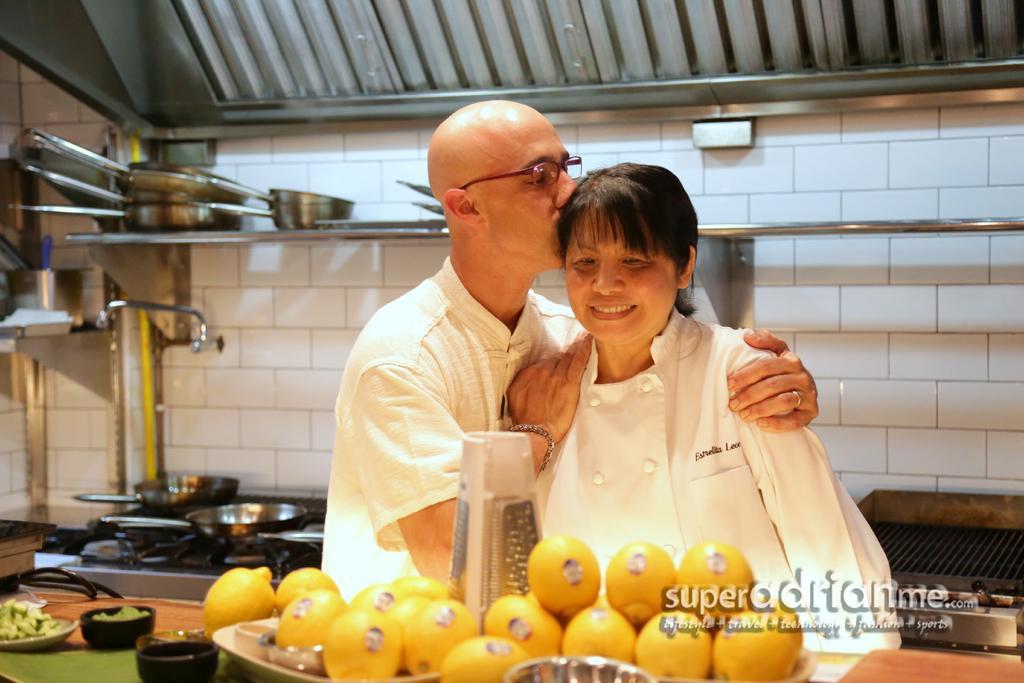Please provide a concise description of this image. In this image we can see two persons standing. One person is wearing spectacles. In the foreground we can see group of fruits, bowls and a container placed on the table and some text. In the background, we can see a group of vessels placed on the stove, some bowls placed in racks. 